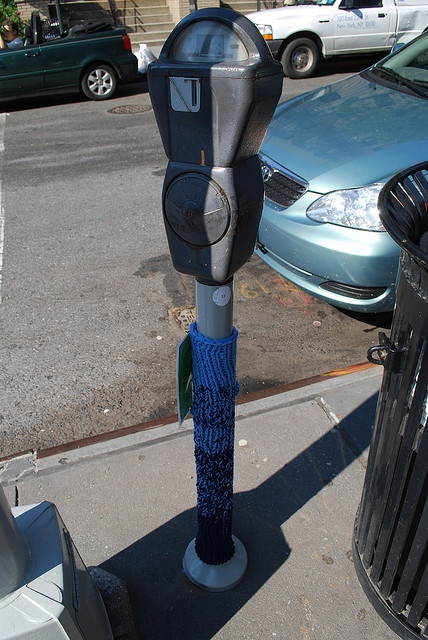Describe the objects in this image and their specific colors. I can see car in darkgreen, gray, white, and blue tones, parking meter in darkgreen, black, gray, and navy tones, car in darkgreen, white, black, darkgray, and gray tones, car in darkgreen, black, gray, teal, and darkblue tones, and people in darkgreen, black, maroon, and gray tones in this image. 